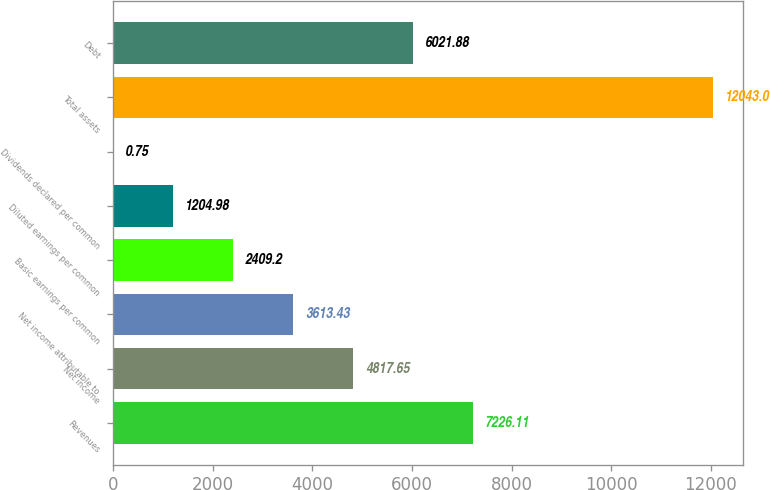Convert chart. <chart><loc_0><loc_0><loc_500><loc_500><bar_chart><fcel>Revenues<fcel>Net income<fcel>Net income attributable to<fcel>Basic earnings per common<fcel>Diluted earnings per common<fcel>Dividends declared per common<fcel>Total assets<fcel>Debt<nl><fcel>7226.11<fcel>4817.65<fcel>3613.43<fcel>2409.2<fcel>1204.98<fcel>0.75<fcel>12043<fcel>6021.88<nl></chart> 